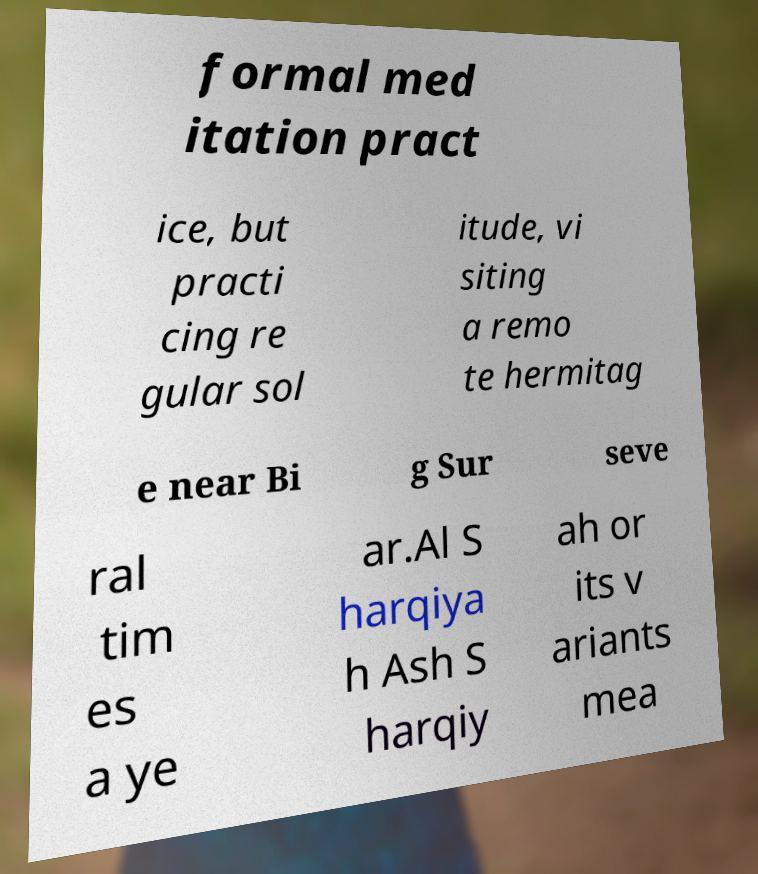I need the written content from this picture converted into text. Can you do that? formal med itation pract ice, but practi cing re gular sol itude, vi siting a remo te hermitag e near Bi g Sur seve ral tim es a ye ar.Al S harqiya h Ash S harqiy ah or its v ariants mea 